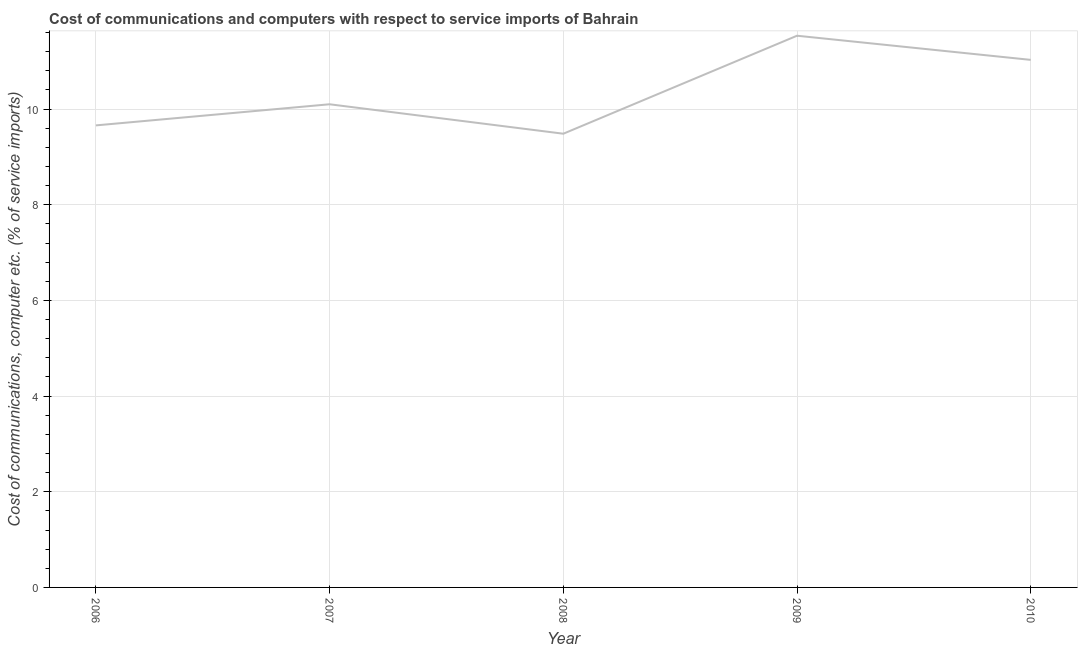What is the cost of communications and computer in 2006?
Provide a short and direct response. 9.66. Across all years, what is the maximum cost of communications and computer?
Keep it short and to the point. 11.53. Across all years, what is the minimum cost of communications and computer?
Your response must be concise. 9.49. In which year was the cost of communications and computer minimum?
Your response must be concise. 2008. What is the sum of the cost of communications and computer?
Make the answer very short. 51.81. What is the difference between the cost of communications and computer in 2008 and 2009?
Your answer should be compact. -2.05. What is the average cost of communications and computer per year?
Your answer should be compact. 10.36. What is the median cost of communications and computer?
Ensure brevity in your answer.  10.1. Do a majority of the years between 2006 and 2008 (inclusive) have cost of communications and computer greater than 2.8 %?
Provide a short and direct response. Yes. What is the ratio of the cost of communications and computer in 2006 to that in 2009?
Provide a succinct answer. 0.84. Is the cost of communications and computer in 2006 less than that in 2008?
Offer a terse response. No. What is the difference between the highest and the second highest cost of communications and computer?
Offer a very short reply. 0.5. What is the difference between the highest and the lowest cost of communications and computer?
Make the answer very short. 2.05. Does the cost of communications and computer monotonically increase over the years?
Keep it short and to the point. No. How many years are there in the graph?
Your answer should be compact. 5. Does the graph contain any zero values?
Your answer should be very brief. No. Does the graph contain grids?
Ensure brevity in your answer.  Yes. What is the title of the graph?
Your answer should be very brief. Cost of communications and computers with respect to service imports of Bahrain. What is the label or title of the X-axis?
Ensure brevity in your answer.  Year. What is the label or title of the Y-axis?
Give a very brief answer. Cost of communications, computer etc. (% of service imports). What is the Cost of communications, computer etc. (% of service imports) of 2006?
Give a very brief answer. 9.66. What is the Cost of communications, computer etc. (% of service imports) of 2007?
Your response must be concise. 10.1. What is the Cost of communications, computer etc. (% of service imports) of 2008?
Give a very brief answer. 9.49. What is the Cost of communications, computer etc. (% of service imports) in 2009?
Offer a terse response. 11.53. What is the Cost of communications, computer etc. (% of service imports) of 2010?
Your response must be concise. 11.03. What is the difference between the Cost of communications, computer etc. (% of service imports) in 2006 and 2007?
Make the answer very short. -0.44. What is the difference between the Cost of communications, computer etc. (% of service imports) in 2006 and 2008?
Give a very brief answer. 0.17. What is the difference between the Cost of communications, computer etc. (% of service imports) in 2006 and 2009?
Your answer should be compact. -1.87. What is the difference between the Cost of communications, computer etc. (% of service imports) in 2006 and 2010?
Offer a terse response. -1.37. What is the difference between the Cost of communications, computer etc. (% of service imports) in 2007 and 2008?
Offer a terse response. 0.62. What is the difference between the Cost of communications, computer etc. (% of service imports) in 2007 and 2009?
Offer a terse response. -1.43. What is the difference between the Cost of communications, computer etc. (% of service imports) in 2007 and 2010?
Keep it short and to the point. -0.93. What is the difference between the Cost of communications, computer etc. (% of service imports) in 2008 and 2009?
Provide a succinct answer. -2.05. What is the difference between the Cost of communications, computer etc. (% of service imports) in 2008 and 2010?
Make the answer very short. -1.54. What is the difference between the Cost of communications, computer etc. (% of service imports) in 2009 and 2010?
Offer a very short reply. 0.5. What is the ratio of the Cost of communications, computer etc. (% of service imports) in 2006 to that in 2007?
Your answer should be very brief. 0.96. What is the ratio of the Cost of communications, computer etc. (% of service imports) in 2006 to that in 2008?
Your response must be concise. 1.02. What is the ratio of the Cost of communications, computer etc. (% of service imports) in 2006 to that in 2009?
Make the answer very short. 0.84. What is the ratio of the Cost of communications, computer etc. (% of service imports) in 2006 to that in 2010?
Keep it short and to the point. 0.88. What is the ratio of the Cost of communications, computer etc. (% of service imports) in 2007 to that in 2008?
Provide a short and direct response. 1.06. What is the ratio of the Cost of communications, computer etc. (% of service imports) in 2007 to that in 2009?
Make the answer very short. 0.88. What is the ratio of the Cost of communications, computer etc. (% of service imports) in 2007 to that in 2010?
Provide a short and direct response. 0.92. What is the ratio of the Cost of communications, computer etc. (% of service imports) in 2008 to that in 2009?
Offer a very short reply. 0.82. What is the ratio of the Cost of communications, computer etc. (% of service imports) in 2008 to that in 2010?
Offer a terse response. 0.86. What is the ratio of the Cost of communications, computer etc. (% of service imports) in 2009 to that in 2010?
Your answer should be very brief. 1.05. 